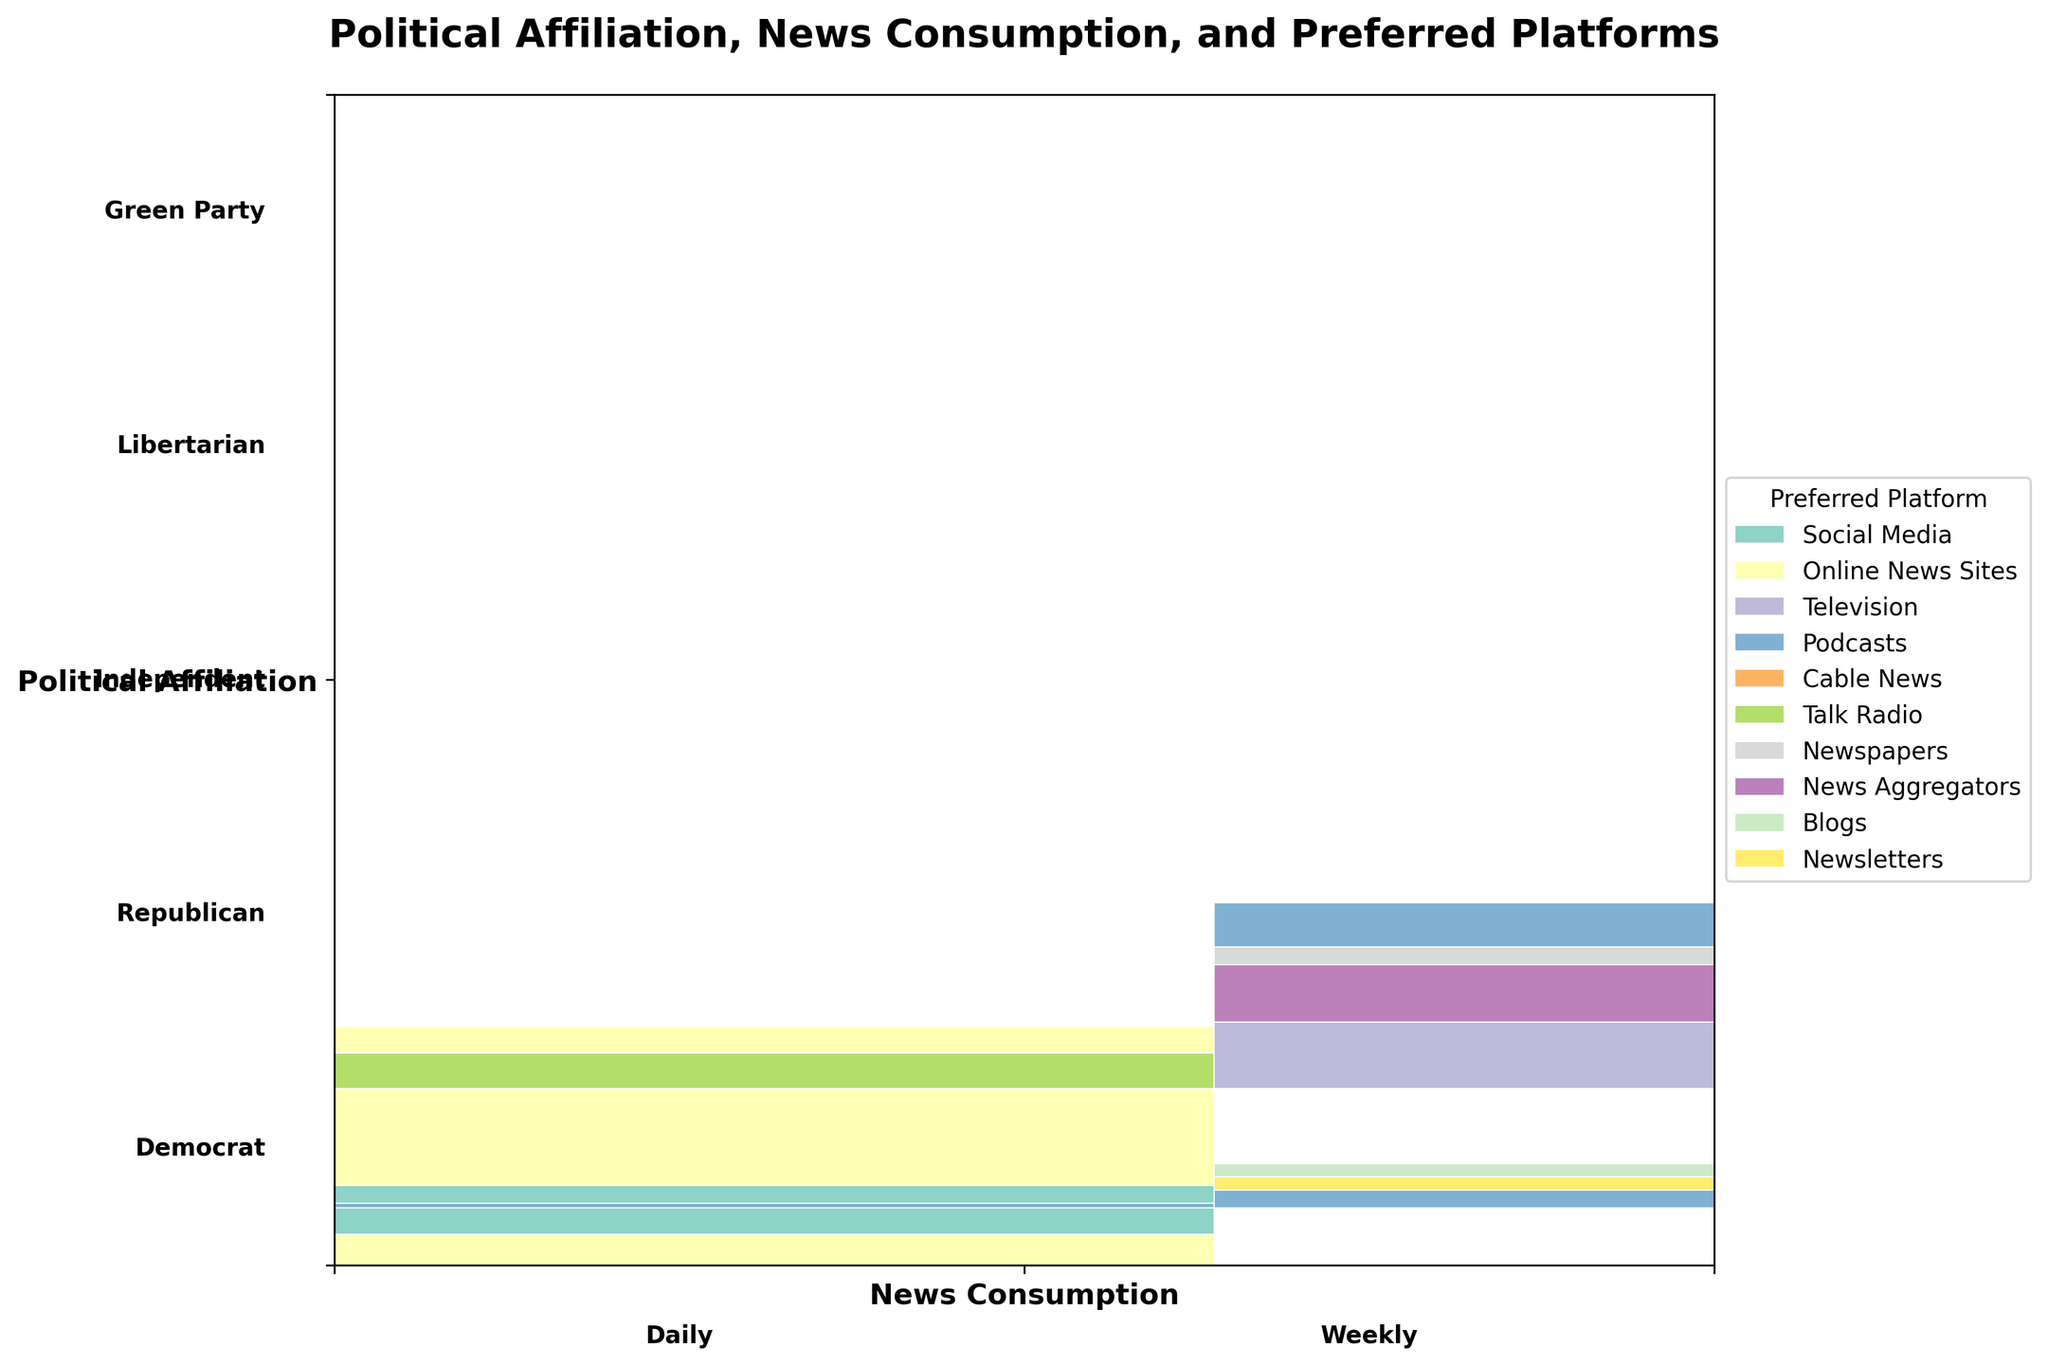What is the title of the mosaic plot? The title is clearly stated at the top of the mosaic plot.
Answer: "Political Affiliation, News Consumption, and Preferred Platforms" What are the political affiliations displayed on the y-axis? The y-axis labels list all the political affiliations present in the data.
Answer: Democrat, Republican, Independent, Libertarian, Green Party Which political affiliation has the smallest section for weekly news consumption through newspapers? Identify the smallest section under weekly news consumption labeled with "Newspapers" and trace back to the corresponding political affiliation displayed on the y-axis.
Answer: Republican How many news consumption categories are there and what are they? The x-axis of the plot shows the news consumption categories, spread out in distinct sections.
Answer: Daily, Weekly Comparing Social Media usage for daily news consumption, which political affiliation has the largest section? Compare the sizes of sections labeled "Social Media" under daily news consumption for each political affiliation on the y-axis.
Answer: Democrat Among the political affiliations, which one has the largest proportion of podcast listeners for daily news consumption? Look at the sections labeled "Podcasts" under daily news consumption and compare their sizes across all political affiliations.
Answer: Libertarian For weekly news consumption through social media, which political affiliation has the highest count? Identify and compare the sizes of the "Social Media" sections under weekly news consumption for each political affiliation.
Answer: Libertarian Which platform is preferred the least by Democrats for both daily and weekly news consumption combined? Locate and compare the total sizes of all the sections corresponding to the platforms for Democrats in both daily and weekly news consumption.
Answer: Podcasts How does the combined section size for Independent’s daily consumption of online news sites compare with their weekly consumption of news aggregators? Measure the sizes of sections "Online News Sites" in daily consumption and "News Aggregators" in weekly consumption, then compare their total areas.
Answer: The daily consumption of online news sites is larger What is the combined count of platforms preferred by the Green Party for their weekly news consumption? Sum up the counts for each platform under weekly consumption for the Green Party (Podcasts and Newsletters).
Answer: 35 